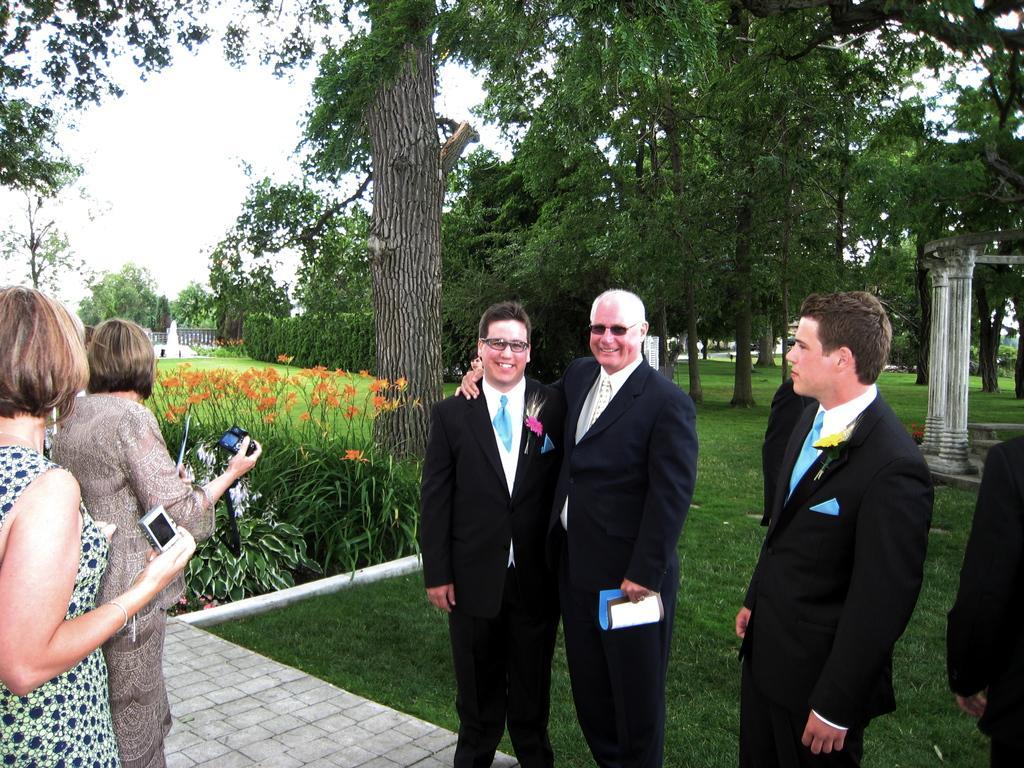How would you summarize this image in a sentence or two? In this picture I can see there are two women standing and they are holding cameras and there are few men standing on to right side and they are wearing blazers and spectacles and they are smiling. There is grass on the floor. In the backdrop there are trees and the sky is clear. 